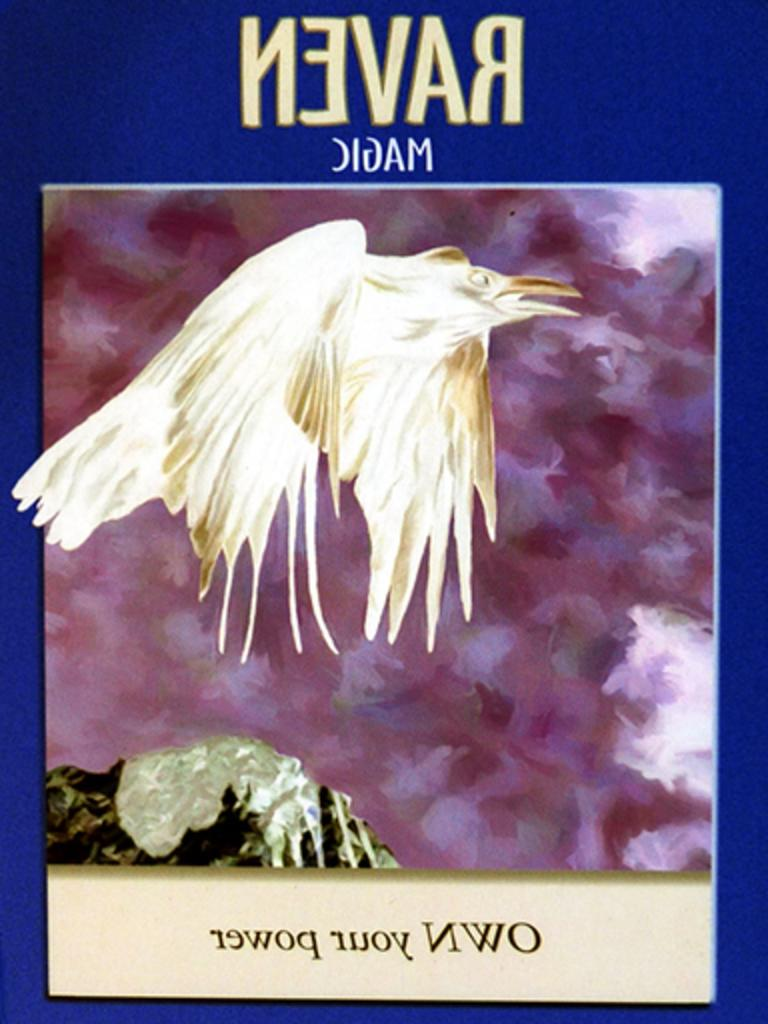What is the main subject of the poster in the image? The poster features a bird. What else can be seen on the poster besides the bird? There is text on the poster. What is the purpose of the spoon in the image? There is no spoon present in the image. 